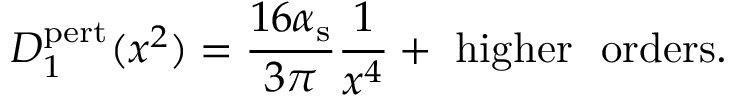<formula> <loc_0><loc_0><loc_500><loc_500>D _ { 1 } ^ { p e r t } ( x ^ { 2 } ) = { \frac { 1 6 \alpha _ { s } } { 3 \pi } } { \frac { 1 } { x ^ { 4 } } } + h i g h e r o r d e r s .</formula> 